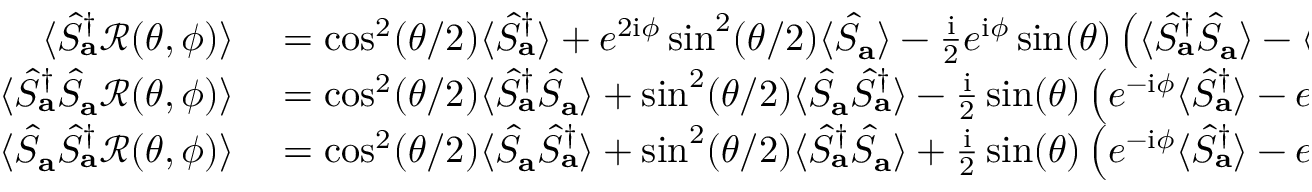<formula> <loc_0><loc_0><loc_500><loc_500>\begin{array} { r l } { \langle \hat { S } _ { a } ^ { \dagger } \mathcal { R } ( \theta , \phi ) \rangle } & = \cos ^ { 2 } ( \theta / 2 ) \langle \hat { S } _ { a } ^ { \dagger } \rangle + e ^ { 2 i \phi } \sin ^ { 2 } ( \theta / 2 ) \langle \hat { S } _ { a } \rangle - \frac { i } { 2 } e ^ { i \phi } \sin ( \theta ) \left ( \langle \hat { S } _ { a } ^ { \dagger } \hat { S } _ { a } \rangle - \langle \hat { S } _ { a } \hat { S } _ { a } ^ { \dagger } \rangle \right ) } \\ { \langle \hat { S } _ { a } ^ { \dagger } \hat { S } _ { a } \mathcal { R } ( \theta , \phi ) \rangle } & = \cos ^ { 2 } ( \theta / 2 ) \langle \hat { S } _ { a } ^ { \dagger } \hat { S } _ { a } \rangle + \sin ^ { 2 } ( \theta / 2 ) \langle \hat { S } _ { a } \hat { S } _ { a } ^ { \dagger } \rangle - \frac { i } { 2 } \sin ( \theta ) \left ( e ^ { - i \phi } \langle \hat { S } _ { a } ^ { \dagger } \rangle - e ^ { i \phi } \langle \hat { S } _ { a } \rangle \right ) } \\ { \langle \hat { S } _ { a } \hat { S } _ { a } ^ { \dagger } \mathcal { R } ( \theta , \phi ) \rangle } & = \cos ^ { 2 } ( \theta / 2 ) \langle \hat { S } _ { a } \hat { S } _ { a } ^ { \dagger } \rangle + \sin ^ { 2 } ( \theta / 2 ) \langle \hat { S } _ { a } ^ { \dagger } \hat { S } _ { a } \rangle + \frac { i } { 2 } \sin ( \theta ) \left ( e ^ { - i \phi } \langle \hat { S } _ { a } ^ { \dagger } \rangle - e ^ { i \phi } \langle \hat { S } _ { a } \rangle \right ) . } \end{array}</formula> 